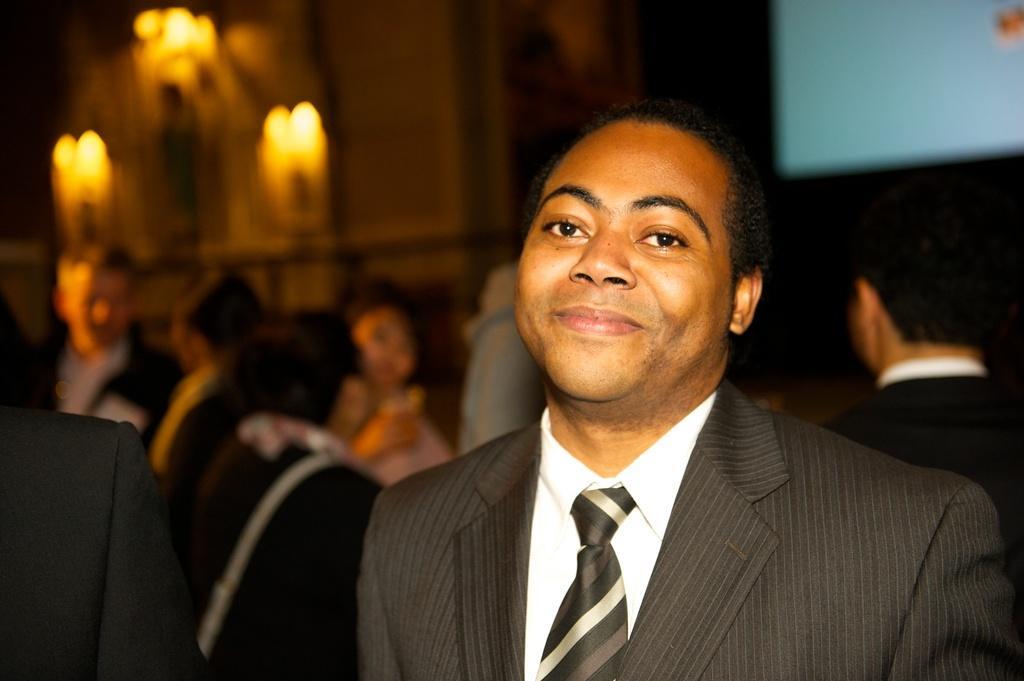Could you give a brief overview of what you see in this image? As we can see in the image there are few people here and there, lights, screen and wall. The person standing in the front is wearing black color jacket. 